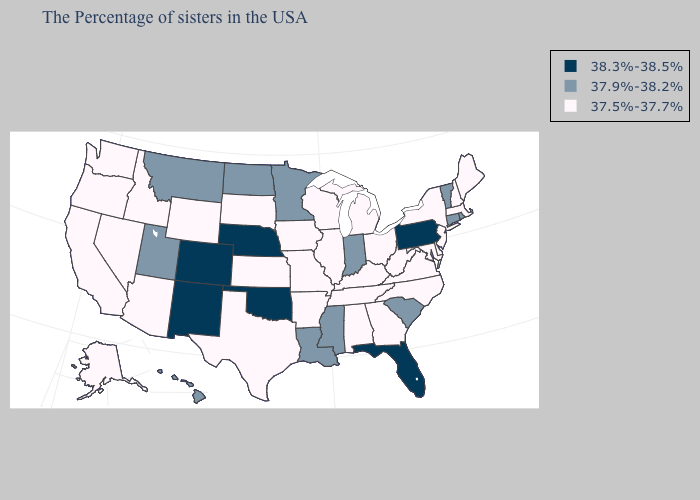Name the states that have a value in the range 38.3%-38.5%?
Write a very short answer. Pennsylvania, Florida, Nebraska, Oklahoma, Colorado, New Mexico. Name the states that have a value in the range 37.9%-38.2%?
Be succinct. Rhode Island, Vermont, Connecticut, South Carolina, Indiana, Mississippi, Louisiana, Minnesota, North Dakota, Utah, Montana, Hawaii. Name the states that have a value in the range 38.3%-38.5%?
Write a very short answer. Pennsylvania, Florida, Nebraska, Oklahoma, Colorado, New Mexico. Does the map have missing data?
Give a very brief answer. No. Name the states that have a value in the range 37.9%-38.2%?
Short answer required. Rhode Island, Vermont, Connecticut, South Carolina, Indiana, Mississippi, Louisiana, Minnesota, North Dakota, Utah, Montana, Hawaii. What is the value of New Mexico?
Short answer required. 38.3%-38.5%. Name the states that have a value in the range 37.5%-37.7%?
Write a very short answer. Maine, Massachusetts, New Hampshire, New York, New Jersey, Delaware, Maryland, Virginia, North Carolina, West Virginia, Ohio, Georgia, Michigan, Kentucky, Alabama, Tennessee, Wisconsin, Illinois, Missouri, Arkansas, Iowa, Kansas, Texas, South Dakota, Wyoming, Arizona, Idaho, Nevada, California, Washington, Oregon, Alaska. What is the highest value in the USA?
Concise answer only. 38.3%-38.5%. What is the lowest value in the South?
Keep it brief. 37.5%-37.7%. Name the states that have a value in the range 37.9%-38.2%?
Short answer required. Rhode Island, Vermont, Connecticut, South Carolina, Indiana, Mississippi, Louisiana, Minnesota, North Dakota, Utah, Montana, Hawaii. Does the first symbol in the legend represent the smallest category?
Answer briefly. No. What is the value of Texas?
Write a very short answer. 37.5%-37.7%. Does Minnesota have a higher value than Kentucky?
Concise answer only. Yes. What is the value of California?
Short answer required. 37.5%-37.7%. What is the highest value in the West ?
Answer briefly. 38.3%-38.5%. 